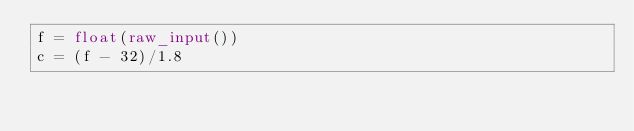Convert code to text. <code><loc_0><loc_0><loc_500><loc_500><_Python_>f = float(raw_input())
c = (f - 32)/1.8</code> 